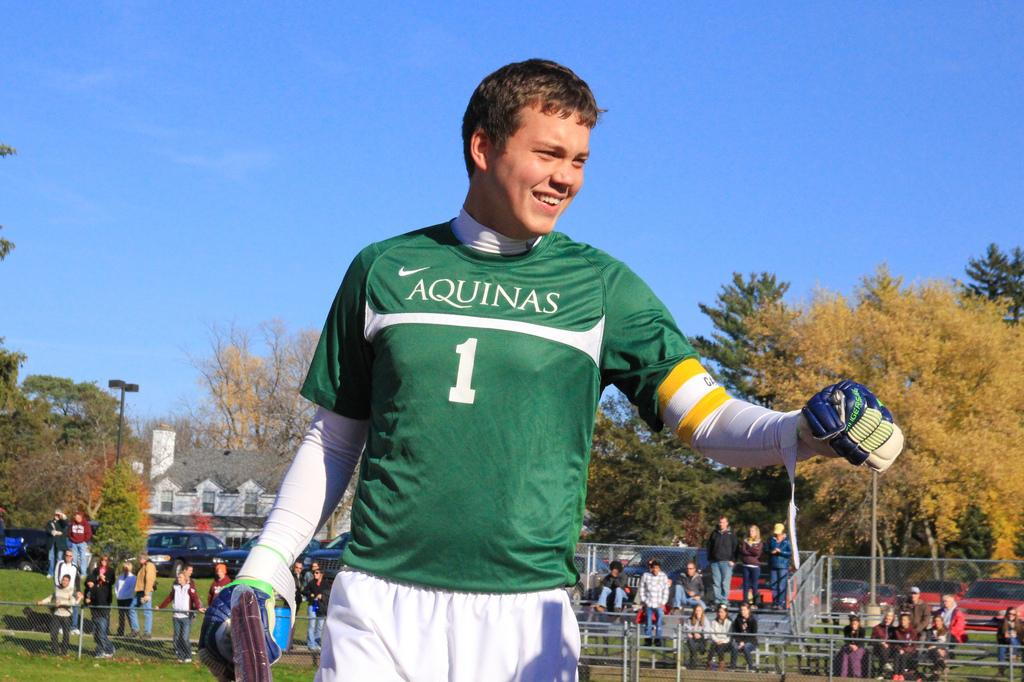<image>
Provide a brief description of the given image. A player wearing a green Aquinas jersey looks happy on the field 